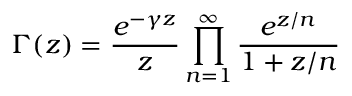Convert formula to latex. <formula><loc_0><loc_0><loc_500><loc_500>\Gamma ( z ) = { \frac { e ^ { - \gamma z } } { z } } \prod _ { n = 1 } ^ { \infty } { \frac { e ^ { z / n } } { 1 + z / n } }</formula> 